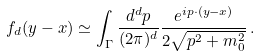Convert formula to latex. <formula><loc_0><loc_0><loc_500><loc_500>f _ { d } ( y - x ) \simeq \int _ { \Gamma } \frac { d ^ { d } p } { ( 2 \pi ) ^ { d } } \frac { e ^ { i p \cdot ( y - x ) } } { 2 \sqrt { p ^ { 2 } + m _ { 0 } ^ { 2 } } } \, .</formula> 